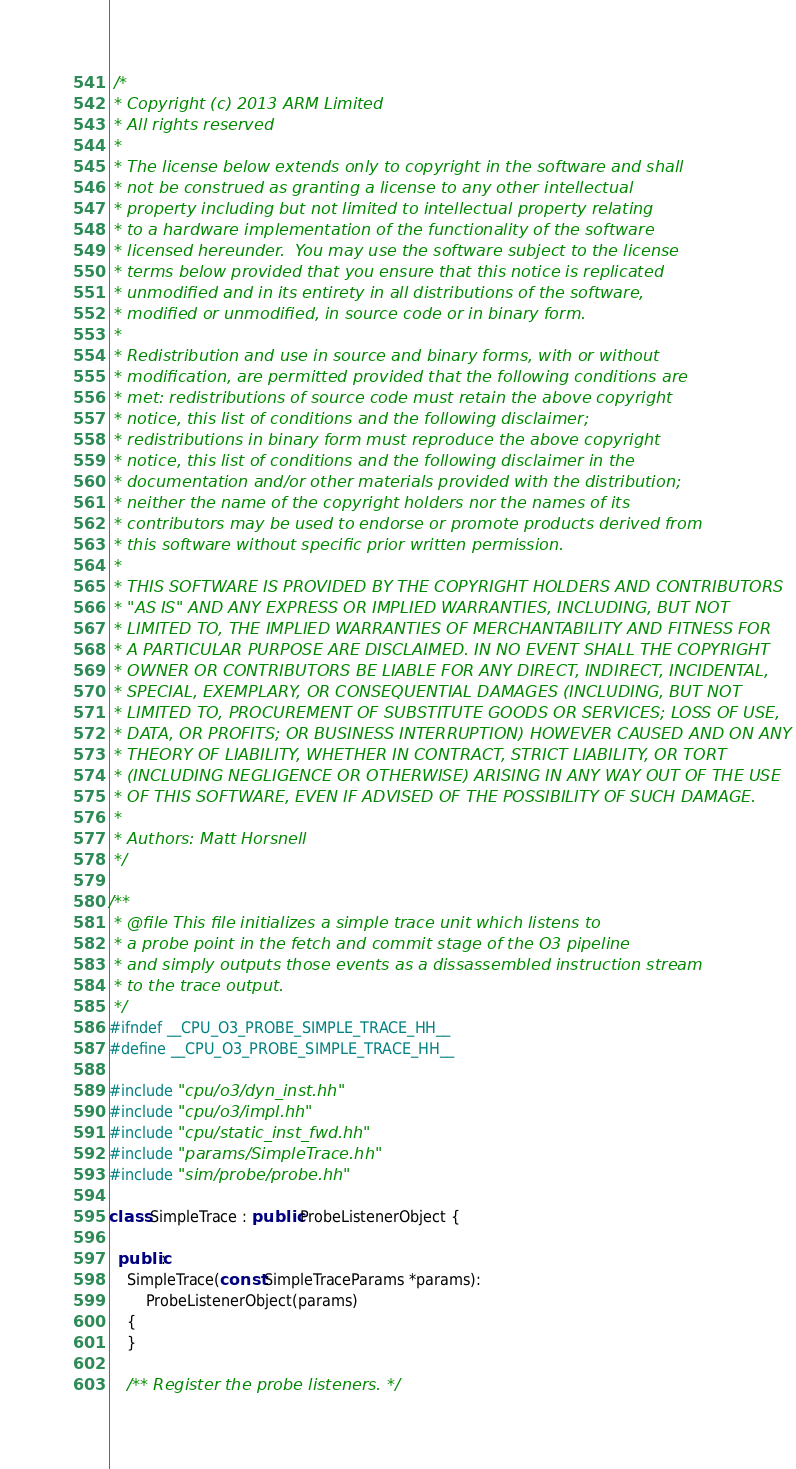<code> <loc_0><loc_0><loc_500><loc_500><_C++_> /*
 * Copyright (c) 2013 ARM Limited
 * All rights reserved
 *
 * The license below extends only to copyright in the software and shall
 * not be construed as granting a license to any other intellectual
 * property including but not limited to intellectual property relating
 * to a hardware implementation of the functionality of the software
 * licensed hereunder.  You may use the software subject to the license
 * terms below provided that you ensure that this notice is replicated
 * unmodified and in its entirety in all distributions of the software,
 * modified or unmodified, in source code or in binary form.
 *
 * Redistribution and use in source and binary forms, with or without
 * modification, are permitted provided that the following conditions are
 * met: redistributions of source code must retain the above copyright
 * notice, this list of conditions and the following disclaimer;
 * redistributions in binary form must reproduce the above copyright
 * notice, this list of conditions and the following disclaimer in the
 * documentation and/or other materials provided with the distribution;
 * neither the name of the copyright holders nor the names of its
 * contributors may be used to endorse or promote products derived from
 * this software without specific prior written permission.
 *
 * THIS SOFTWARE IS PROVIDED BY THE COPYRIGHT HOLDERS AND CONTRIBUTORS
 * "AS IS" AND ANY EXPRESS OR IMPLIED WARRANTIES, INCLUDING, BUT NOT
 * LIMITED TO, THE IMPLIED WARRANTIES OF MERCHANTABILITY AND FITNESS FOR
 * A PARTICULAR PURPOSE ARE DISCLAIMED. IN NO EVENT SHALL THE COPYRIGHT
 * OWNER OR CONTRIBUTORS BE LIABLE FOR ANY DIRECT, INDIRECT, INCIDENTAL,
 * SPECIAL, EXEMPLARY, OR CONSEQUENTIAL DAMAGES (INCLUDING, BUT NOT
 * LIMITED TO, PROCUREMENT OF SUBSTITUTE GOODS OR SERVICES; LOSS OF USE,
 * DATA, OR PROFITS; OR BUSINESS INTERRUPTION) HOWEVER CAUSED AND ON ANY
 * THEORY OF LIABILITY, WHETHER IN CONTRACT, STRICT LIABILITY, OR TORT
 * (INCLUDING NEGLIGENCE OR OTHERWISE) ARISING IN ANY WAY OUT OF THE USE
 * OF THIS SOFTWARE, EVEN IF ADVISED OF THE POSSIBILITY OF SUCH DAMAGE.
 *
 * Authors: Matt Horsnell
 */

/**
 * @file This file initializes a simple trace unit which listens to
 * a probe point in the fetch and commit stage of the O3 pipeline
 * and simply outputs those events as a dissassembled instruction stream
 * to the trace output.
 */
#ifndef __CPU_O3_PROBE_SIMPLE_TRACE_HH__
#define __CPU_O3_PROBE_SIMPLE_TRACE_HH__

#include "cpu/o3/dyn_inst.hh"
#include "cpu/o3/impl.hh"
#include "cpu/static_inst_fwd.hh"
#include "params/SimpleTrace.hh"
#include "sim/probe/probe.hh"

class SimpleTrace : public ProbeListenerObject {

  public:
    SimpleTrace(const SimpleTraceParams *params):
        ProbeListenerObject(params)
    {
    }

    /** Register the probe listeners. */</code> 